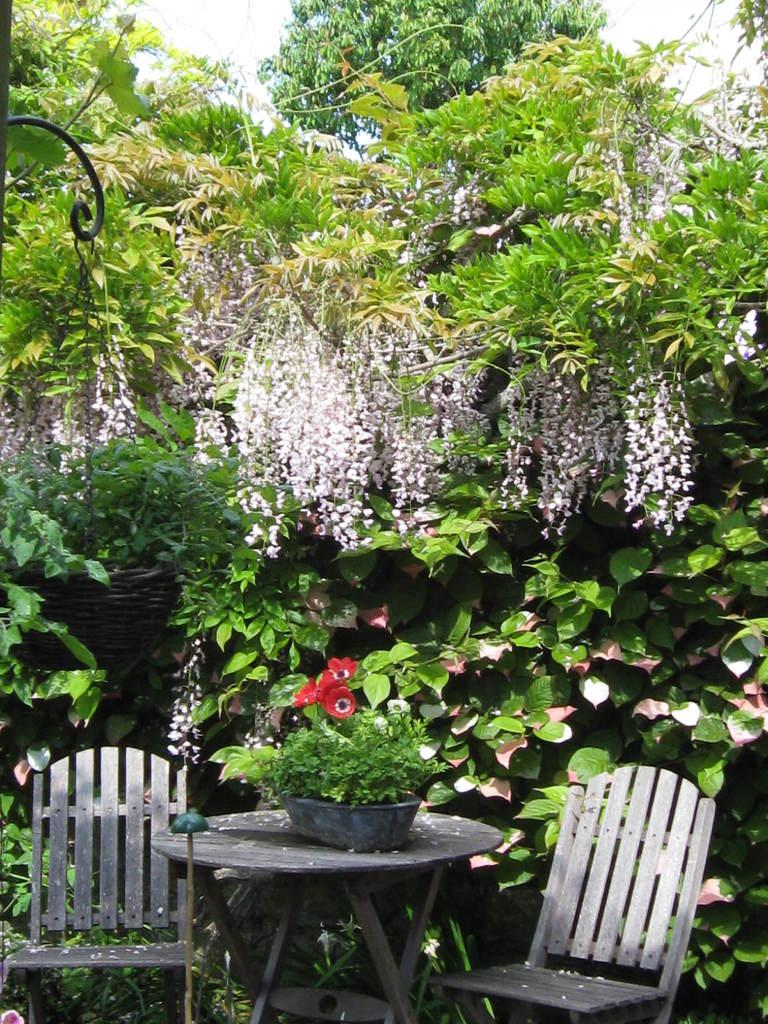What type of furniture is present in the image? There is a table in the image. How many chairs are visible in the image? There are two chairs in the image. What is on the table in the image? There is a pot with a plant on the table. Can you describe the hanging object in the image? There is a hanging pot with a plant in the image. What can be seen in the background of the image? There are trees and flowers in the background of the image. How many branches are visible on the fifth chair in the image? There are no branches mentioned in the image, and there are only two chairs present. Additionally, chairs do not have branches. 